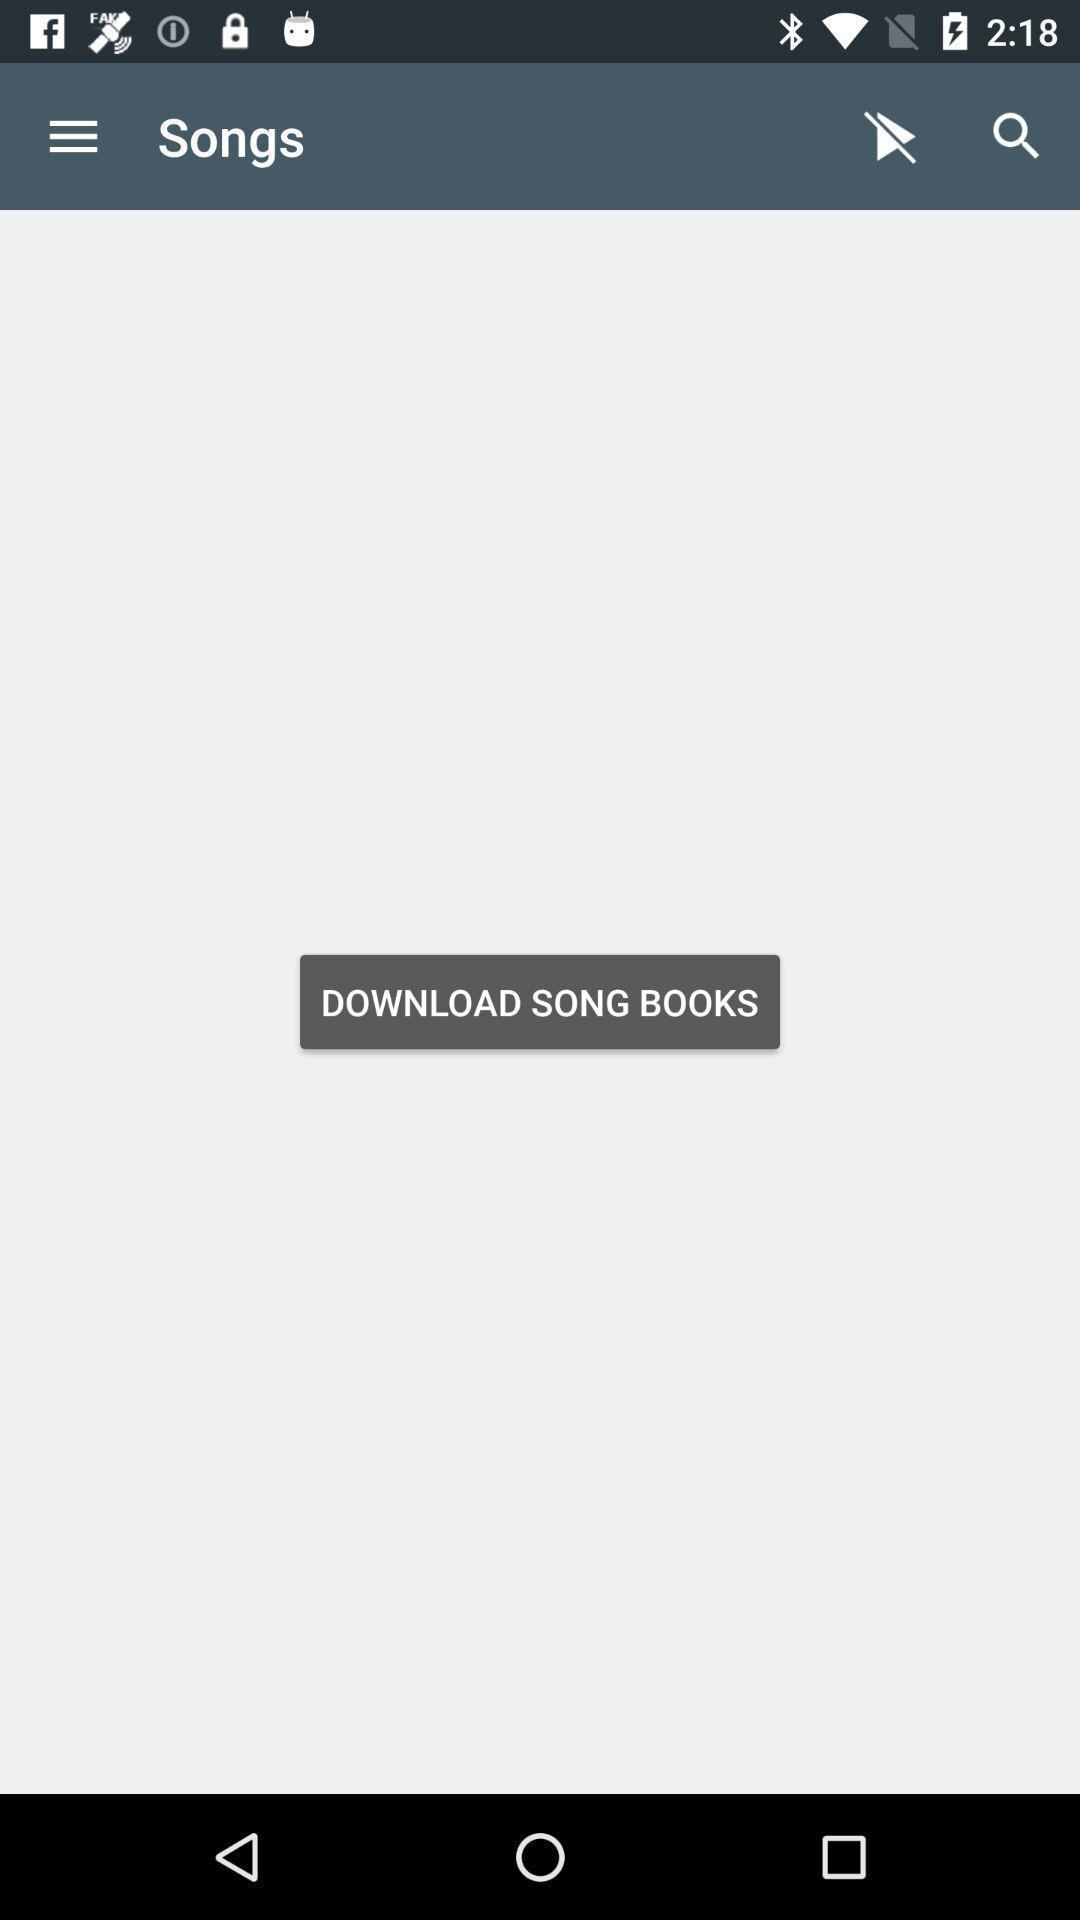Describe the key features of this screenshot. Window displaying the songs page. 